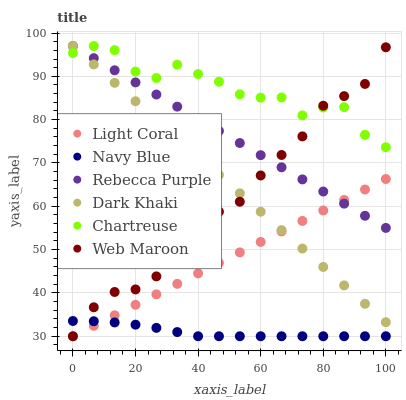Does Navy Blue have the minimum area under the curve?
Answer yes or no. Yes. Does Chartreuse have the maximum area under the curve?
Answer yes or no. Yes. Does Web Maroon have the minimum area under the curve?
Answer yes or no. No. Does Web Maroon have the maximum area under the curve?
Answer yes or no. No. Is Light Coral the smoothest?
Answer yes or no. Yes. Is Chartreuse the roughest?
Answer yes or no. Yes. Is Navy Blue the smoothest?
Answer yes or no. No. Is Navy Blue the roughest?
Answer yes or no. No. Does Navy Blue have the lowest value?
Answer yes or no. Yes. Does Chartreuse have the lowest value?
Answer yes or no. No. Does Rebecca Purple have the highest value?
Answer yes or no. Yes. Does Web Maroon have the highest value?
Answer yes or no. No. Is Light Coral less than Chartreuse?
Answer yes or no. Yes. Is Chartreuse greater than Navy Blue?
Answer yes or no. Yes. Does Web Maroon intersect Rebecca Purple?
Answer yes or no. Yes. Is Web Maroon less than Rebecca Purple?
Answer yes or no. No. Is Web Maroon greater than Rebecca Purple?
Answer yes or no. No. Does Light Coral intersect Chartreuse?
Answer yes or no. No. 